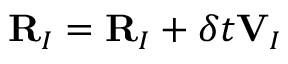<formula> <loc_0><loc_0><loc_500><loc_500>{ R } _ { I } = { R } _ { I } + \delta t { V } _ { I }</formula> 